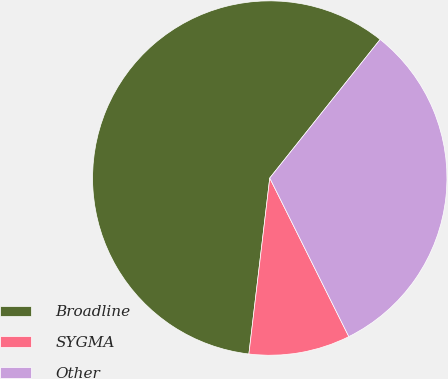Convert chart to OTSL. <chart><loc_0><loc_0><loc_500><loc_500><pie_chart><fcel>Broadline<fcel>SYGMA<fcel>Other<nl><fcel>58.82%<fcel>9.24%<fcel>31.93%<nl></chart> 